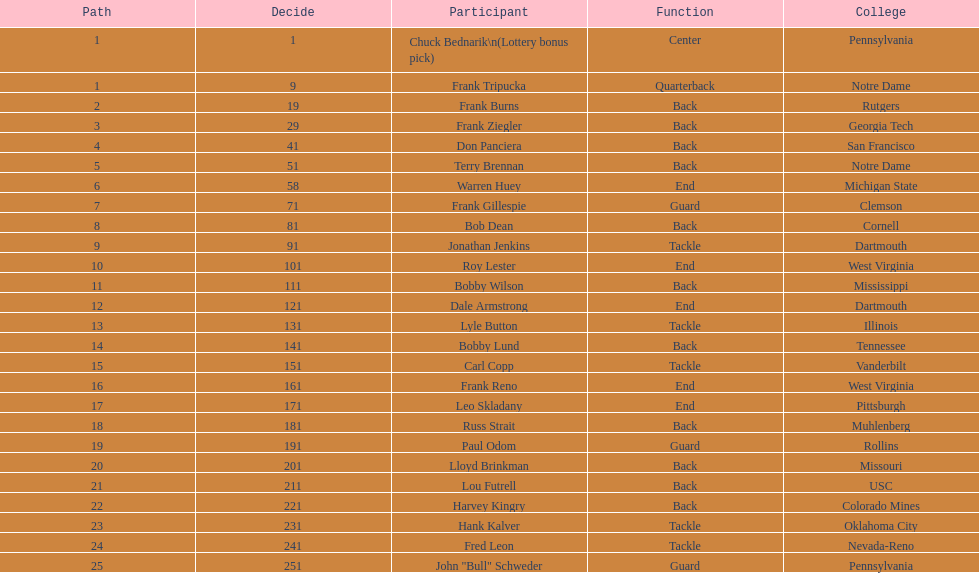Was it chuck bednarik or frank tripucka who was the first draft choice? Chuck Bednarik. 